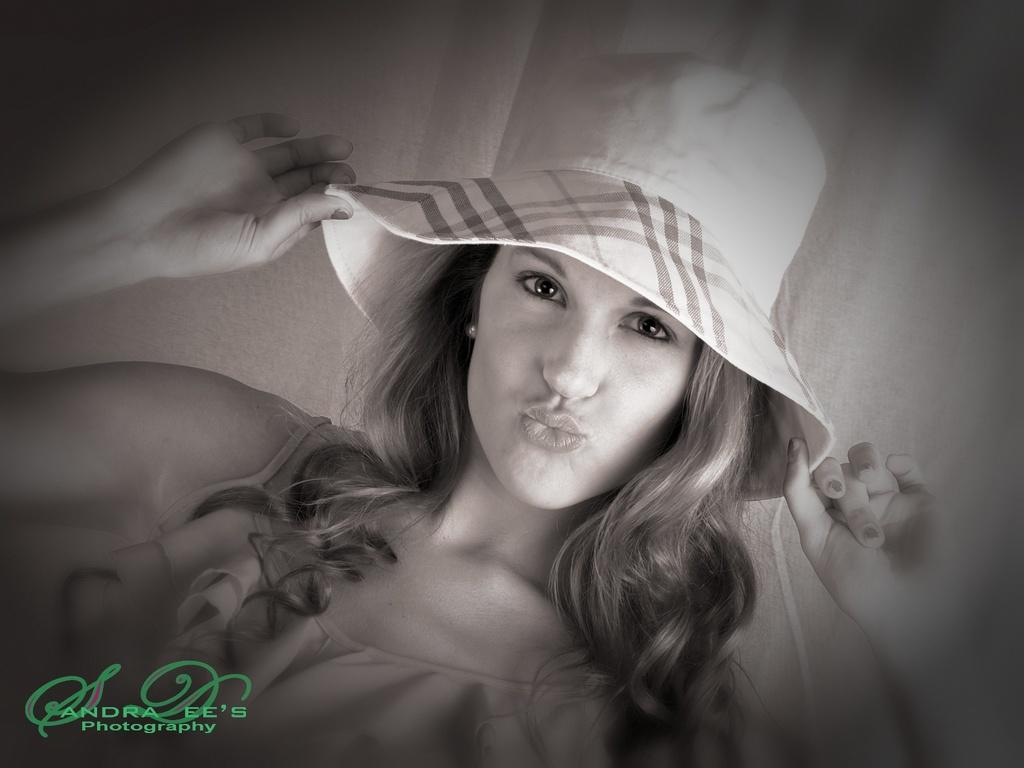Who is present in the image? There is a woman in the image. What is the woman holding? The woman is holding a hat. Can you describe any additional features of the image? A watermark is visible on the left side of the image. What type of wood is used to make the pickle in the image? There is no pickle present in the image, and therefore no wood or pickle-making can be observed. 